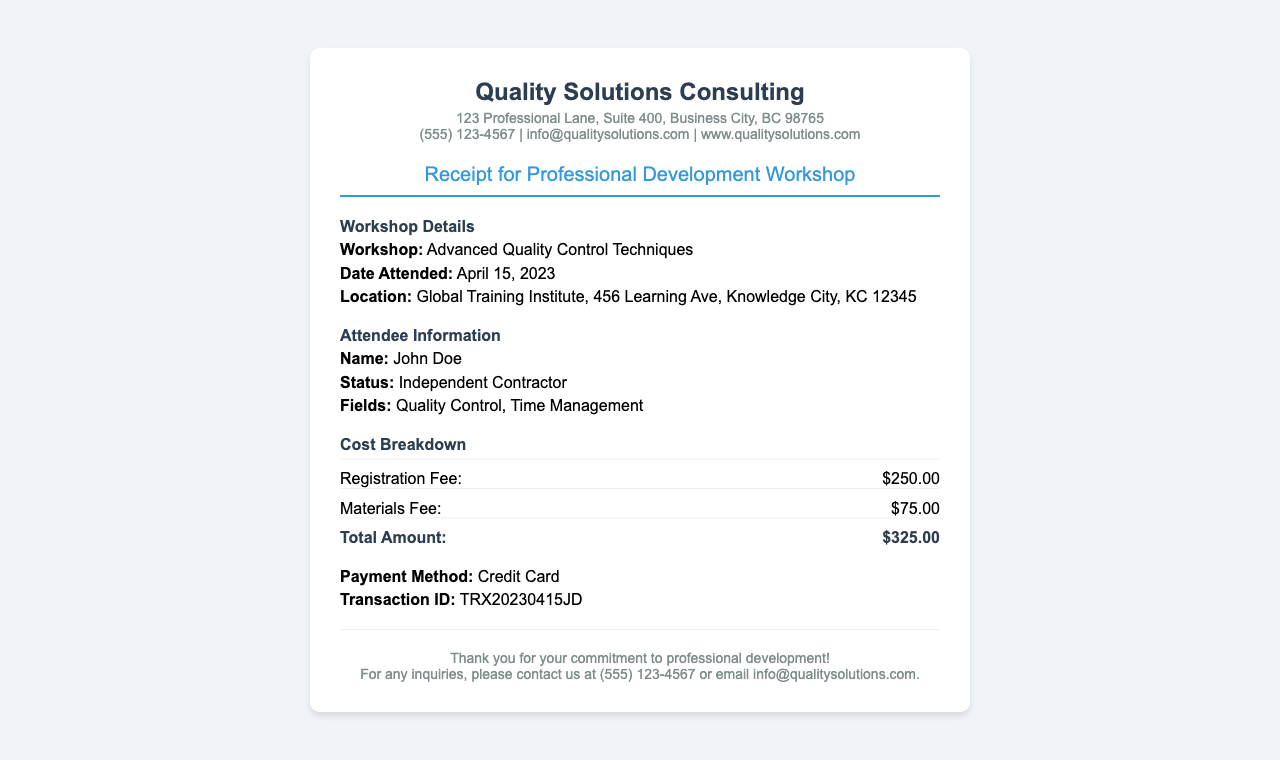What is the name of the workshop? The name of the workshop is stated in the document under Workshop Details.
Answer: Advanced Quality Control Techniques When was the workshop attended? The date attended is provided in the document details in the Workshop section.
Answer: April 15, 2023 What is the total amount paid for the workshop? The total amount is listed in the Cost Breakdown section, summing registration and materials fees.
Answer: $325.00 Who is the attendee? The name of the attendee can be found in the Attendee Information section.
Answer: John Doe What alternative contact method is provided in the footer? The footer ends with a call to reach out for inquiries, indicating alternatives to the primary contact method.
Answer: Email How much was the materials fee? The materials fee is detailed in the Cost Breakdown section of the receipt.
Answer: $75.00 What was the payment method used? The payment method is specified in the section detailing payment information.
Answer: Credit Card What is the transaction ID for the payment? The transaction ID can be found under payment details in the receipt.
Answer: TRX20230415JD What is the name of the company issuing the receipt? The company's name is clearly mentioned at the top of the receipt in the header section.
Answer: Quality Solutions Consulting 